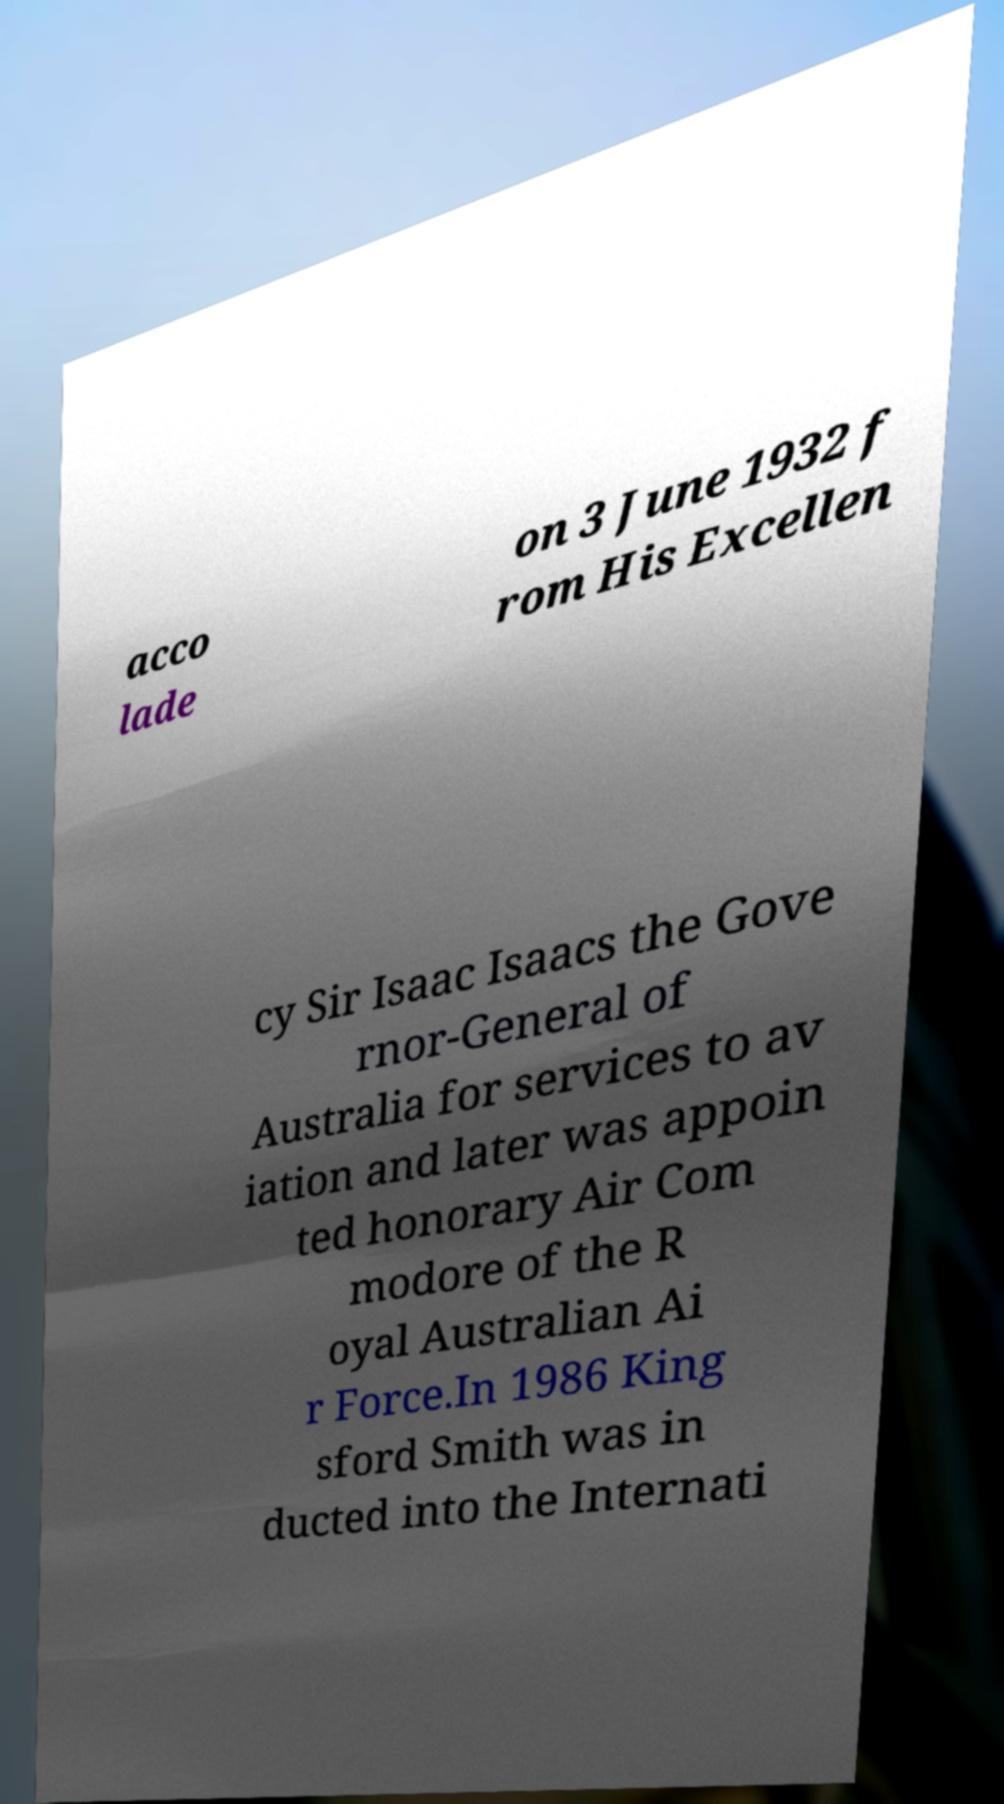Please identify and transcribe the text found in this image. acco lade on 3 June 1932 f rom His Excellen cy Sir Isaac Isaacs the Gove rnor-General of Australia for services to av iation and later was appoin ted honorary Air Com modore of the R oyal Australian Ai r Force.In 1986 King sford Smith was in ducted into the Internati 